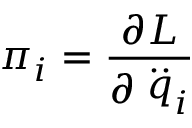Convert formula to latex. <formula><loc_0><loc_0><loc_500><loc_500>\pi _ { i } = \frac { \partial L } { \partial \stackrel { . . } { q } _ { i } }</formula> 